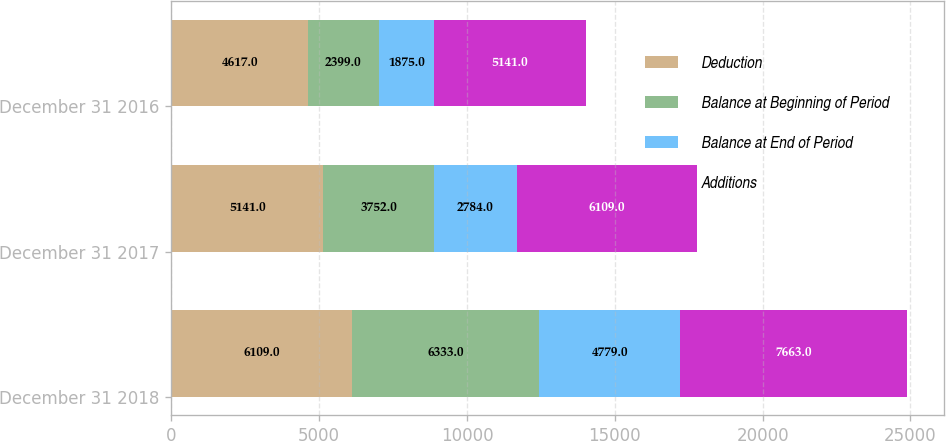Convert chart. <chart><loc_0><loc_0><loc_500><loc_500><stacked_bar_chart><ecel><fcel>December 31 2018<fcel>December 31 2017<fcel>December 31 2016<nl><fcel>Deduction<fcel>6109<fcel>5141<fcel>4617<nl><fcel>Balance at Beginning of Period<fcel>6333<fcel>3752<fcel>2399<nl><fcel>Balance at End of Period<fcel>4779<fcel>2784<fcel>1875<nl><fcel>Additions<fcel>7663<fcel>6109<fcel>5141<nl></chart> 